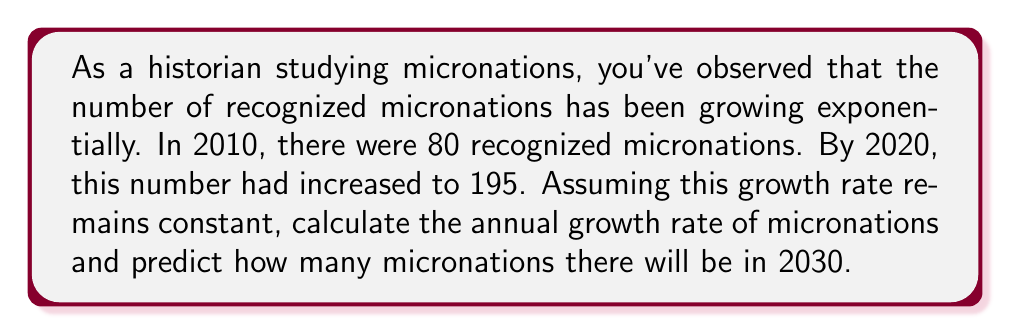Provide a solution to this math problem. To solve this problem, we'll use the exponential growth formula:

$$ A = P(1 + r)^t $$

Where:
$A$ is the final amount
$P$ is the initial amount
$r$ is the annual growth rate
$t$ is the time in years

We know:
$P = 80$ (micronations in 2010)
$A = 195$ (micronations in 2020)
$t = 10$ years

Let's substitute these values into the formula:

$$ 195 = 80(1 + r)^{10} $$

To solve for $r$, we'll follow these steps:

1) Divide both sides by 80:
   $$ \frac{195}{80} = (1 + r)^{10} $$

2) Take the 10th root of both sides:
   $$ \sqrt[10]{\frac{195}{80}} = 1 + r $$

3) Subtract 1 from both sides:
   $$ \sqrt[10]{\frac{195}{80}} - 1 = r $$

4) Calculate the value:
   $$ r \approx 0.0933 \text{ or } 9.33\% $$

Now that we have the annual growth rate, we can predict the number of micronations in 2030:

$$ A = 195(1 + 0.0933)^{10} \approx 474.5 $$

Rounding to the nearest whole number, we predict 475 micronations in 2030.
Answer: The annual growth rate of micronations is approximately 9.33%, and the predicted number of micronations in 2030 is 475. 